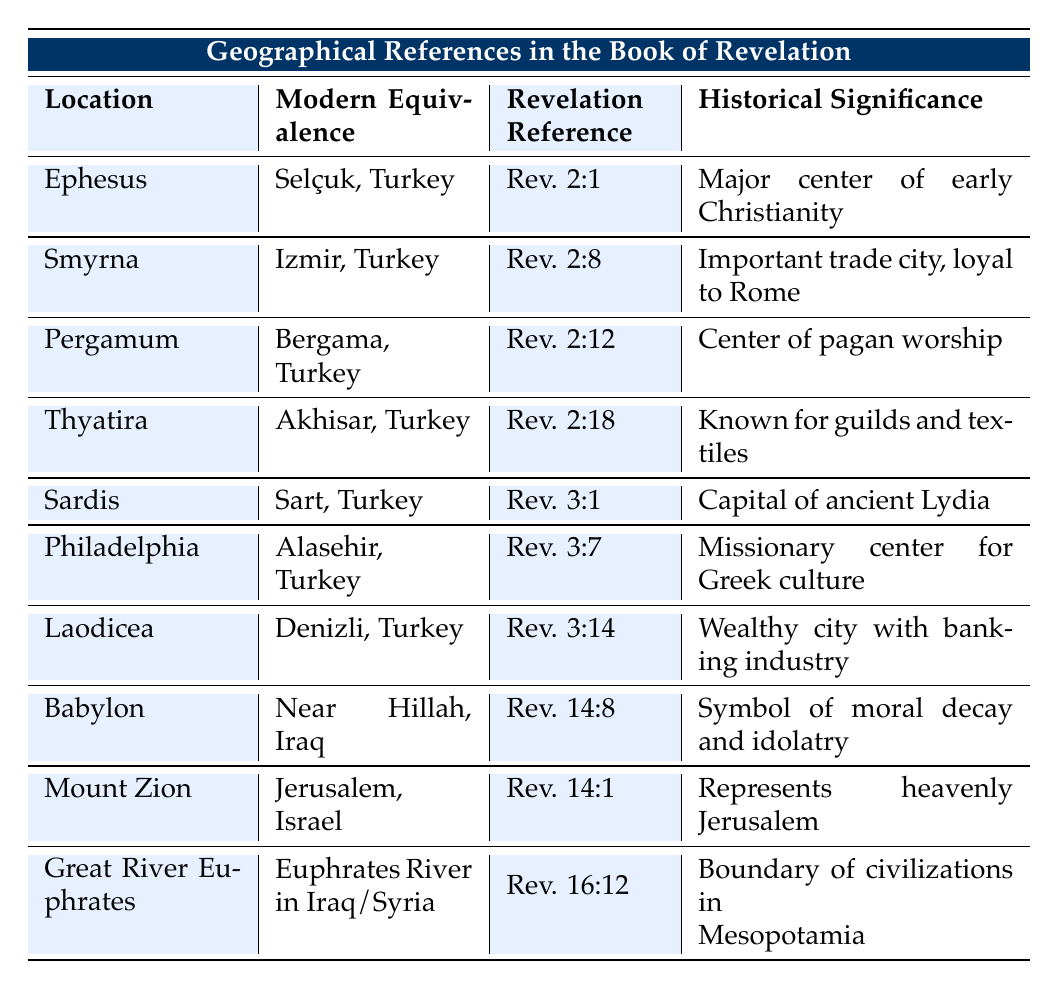What is the modern equivalence of Ephesus? The table lists Ephesus and states its modern equivalence as Selçuk, Turkey.
Answer: Selçuk, Turkey Which location has a Revelation reference of Rev. 3:1? By looking at the Revelation Reference column in the table, Sardis is the location associated with Rev. 3:1.
Answer: Sardis Is Pergamum known for its dedication to Zeus? The Historical Significance of Pergamum in the table explicitly states it is the site of an altar dedicated to Zeus, confirming the fact.
Answer: Yes Which two locations are mentioned as significant cities in early Christianity? Referring to the table, Ephesus and Philadelphia are both noted for their significance in early Christianity, with Ephesus as a major center and Philadelphia as a missionary center.
Answer: Ephesus and Philadelphia What is the historical significance of Laodicea? The table indicates that Laodicea was a wealthy city renowned for its banking industry, textiles, and medical school, defining its historical importance.
Answer: Wealthy city with banking industry and textiles How many locations in the table are modern cities in Turkey? The table lists a total of 7 locations, all corresponding to modern cities in Turkey. By counting them: Ephesus, Smyrna, Pergamum, Thyatira, Sardis, Philadelphia, and Laodicea, we find they all are in Turkey.
Answer: 7 What does the Great River Euphrates symbolize according to the table? According to the Historical Significance provided in the table, the Great River Euphrates symbolizes the boundary of civilizations in Mesopotamia.
Answer: Boundary of civilizations Which location represents moral decay in the Book of Revelation? The table points to Babylon as symbolizing moral decay and representing a center of idolatry, directly answering the question about its representation in the text.
Answer: Babylon Which Revelation reference is associated with Thyatira? The reference to Thyatira can be found in the Revelation Reference column, which states it is Rev. 2:18.
Answer: Rev. 2:18 What is the significance of Mount Zion in the historical context? The table notes that Mount Zion is significant in Jewish tradition and represents the heavenly Jerusalem, making it integral to the historical context of the Book of Revelation.
Answer: Represents the heavenly Jerusalem 